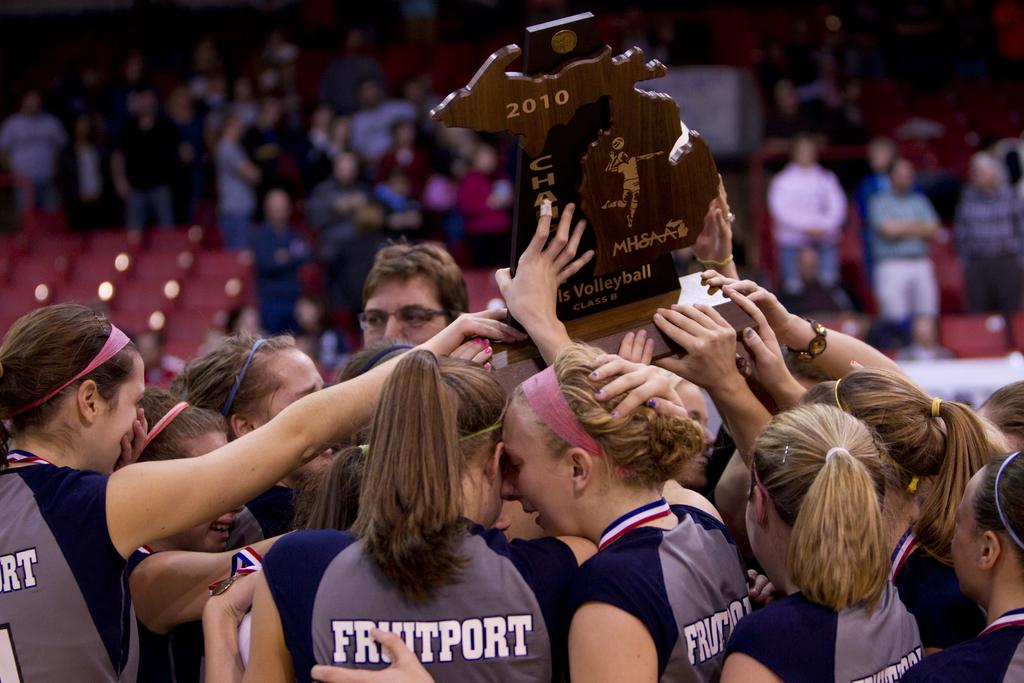<image>
Create a compact narrative representing the image presented. A group of girls wearing Fruitport uniforms huddle around a 2010 volleyball plaque. 